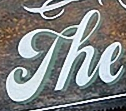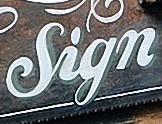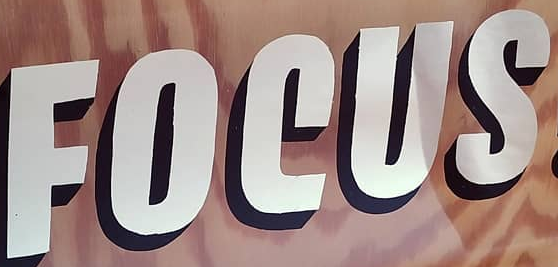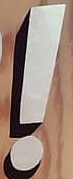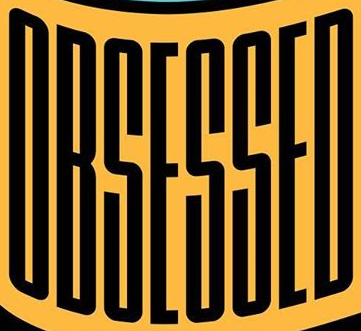What words can you see in these images in sequence, separated by a semicolon? The; Sign; FOCUS; !; OBSESSED 